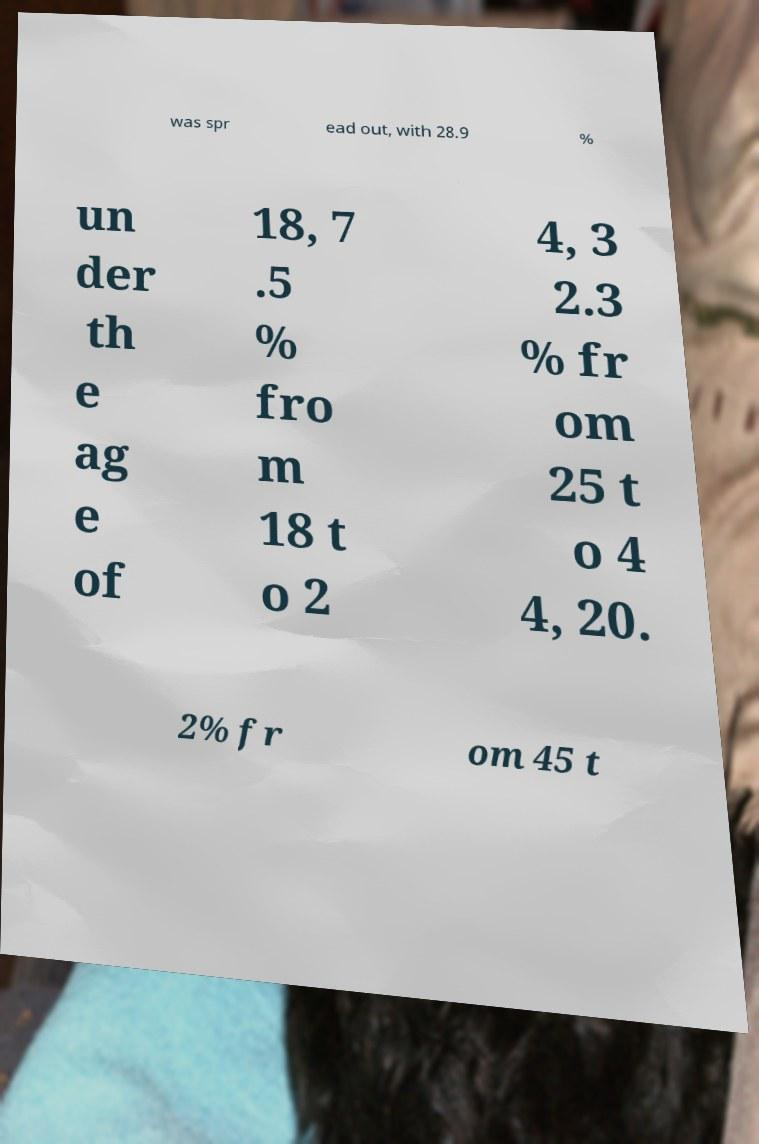For documentation purposes, I need the text within this image transcribed. Could you provide that? was spr ead out, with 28.9 % un der th e ag e of 18, 7 .5 % fro m 18 t o 2 4, 3 2.3 % fr om 25 t o 4 4, 20. 2% fr om 45 t 